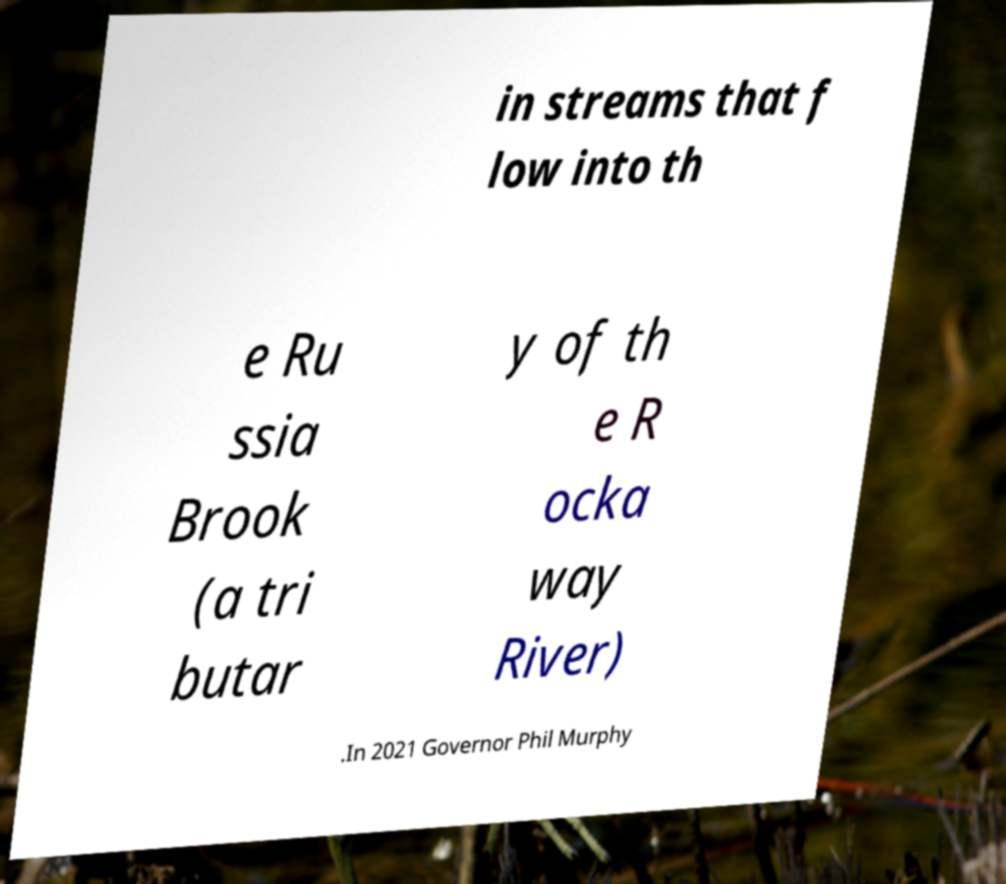There's text embedded in this image that I need extracted. Can you transcribe it verbatim? in streams that f low into th e Ru ssia Brook (a tri butar y of th e R ocka way River) .In 2021 Governor Phil Murphy 